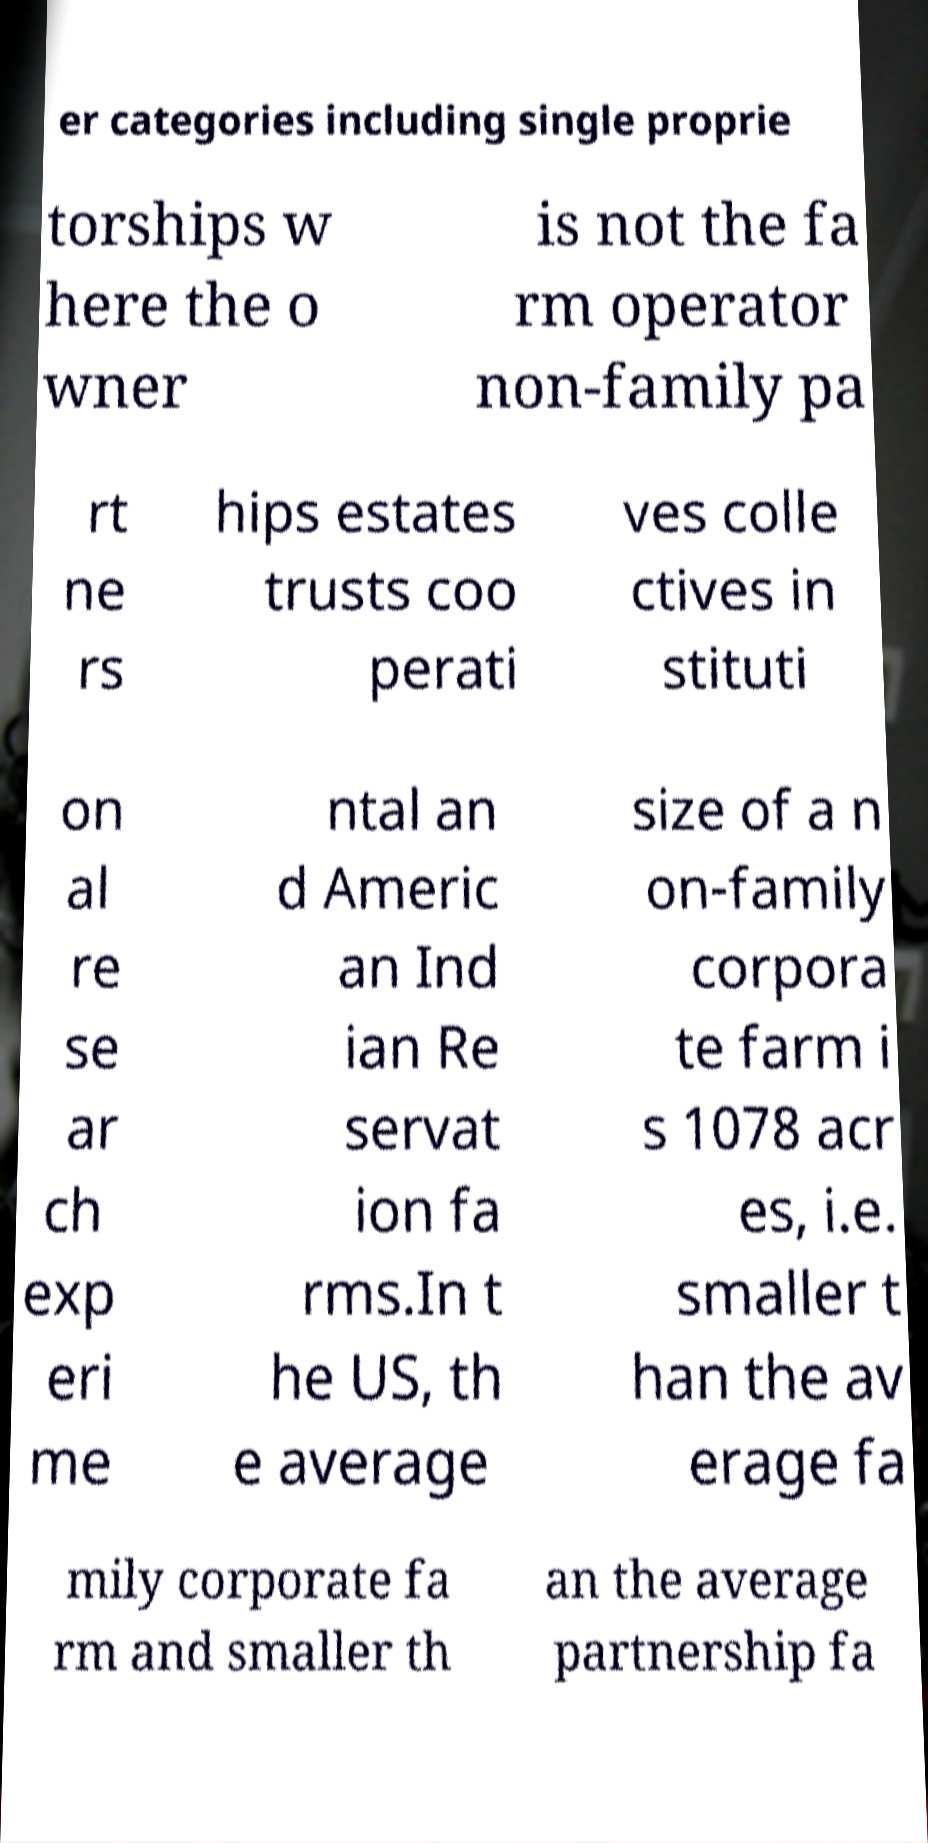I need the written content from this picture converted into text. Can you do that? er categories including single proprie torships w here the o wner is not the fa rm operator non-family pa rt ne rs hips estates trusts coo perati ves colle ctives in stituti on al re se ar ch exp eri me ntal an d Americ an Ind ian Re servat ion fa rms.In t he US, th e average size of a n on-family corpora te farm i s 1078 acr es, i.e. smaller t han the av erage fa mily corporate fa rm and smaller th an the average partnership fa 